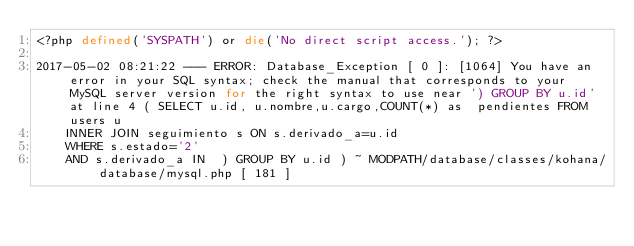Convert code to text. <code><loc_0><loc_0><loc_500><loc_500><_PHP_><?php defined('SYSPATH') or die('No direct script access.'); ?>

2017-05-02 08:21:22 --- ERROR: Database_Exception [ 0 ]: [1064] You have an error in your SQL syntax; check the manual that corresponds to your MySQL server version for the right syntax to use near ') GROUP BY u.id' at line 4 ( SELECT u.id, u.nombre,u.cargo,COUNT(*) as  pendientes FROM users u
    INNER JOIN seguimiento s ON s.derivado_a=u.id
    WHERE s.estado='2'
    AND s.derivado_a IN  ) GROUP BY u.id ) ~ MODPATH/database/classes/kohana/database/mysql.php [ 181 ]</code> 